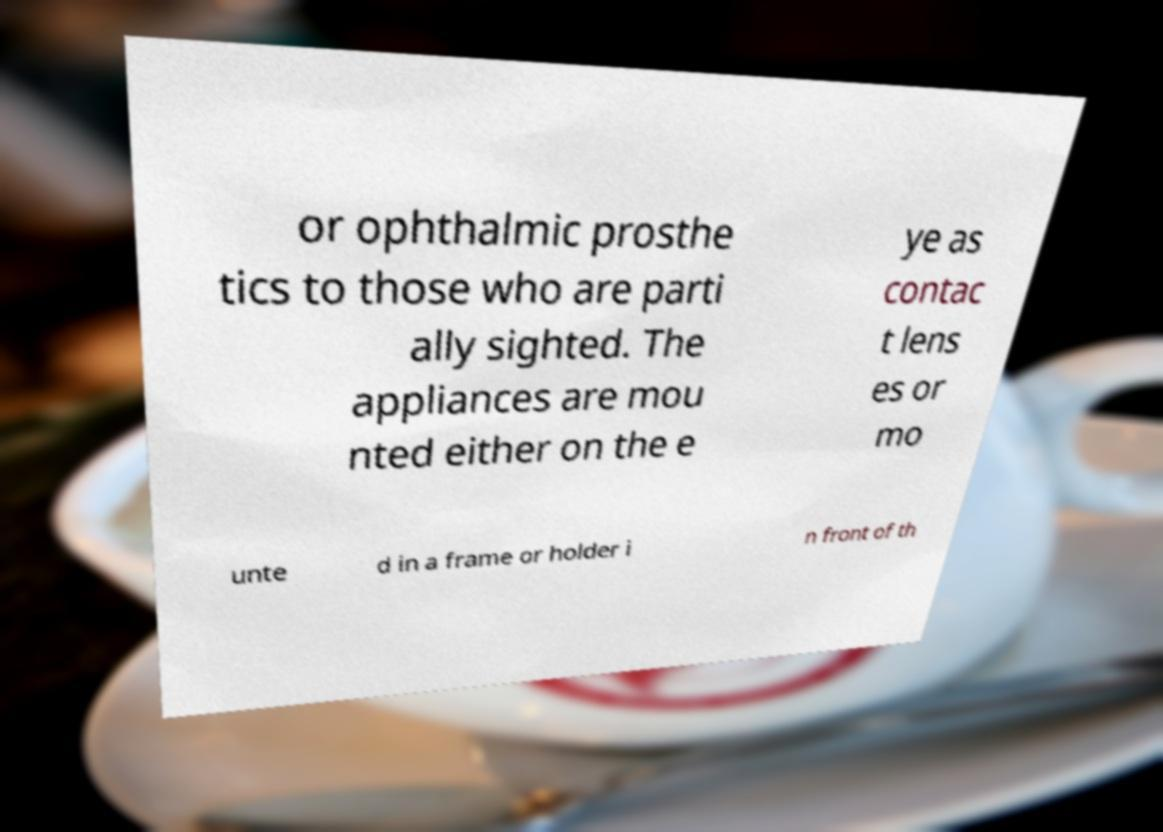Please read and relay the text visible in this image. What does it say? or ophthalmic prosthe tics to those who are parti ally sighted. The appliances are mou nted either on the e ye as contac t lens es or mo unte d in a frame or holder i n front of th 